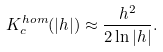<formula> <loc_0><loc_0><loc_500><loc_500>K _ { c } ^ { h o m } ( | h | ) \approx \frac { h ^ { 2 } } { 2 \ln { | h | } } .</formula> 